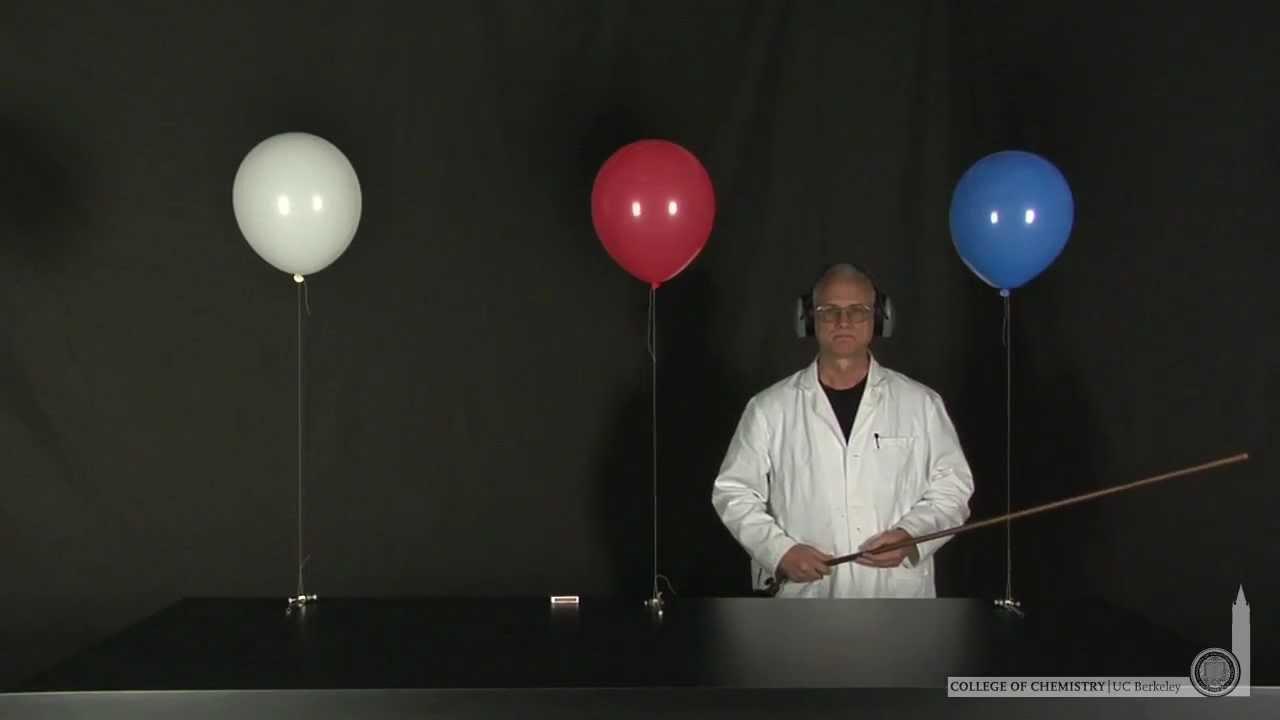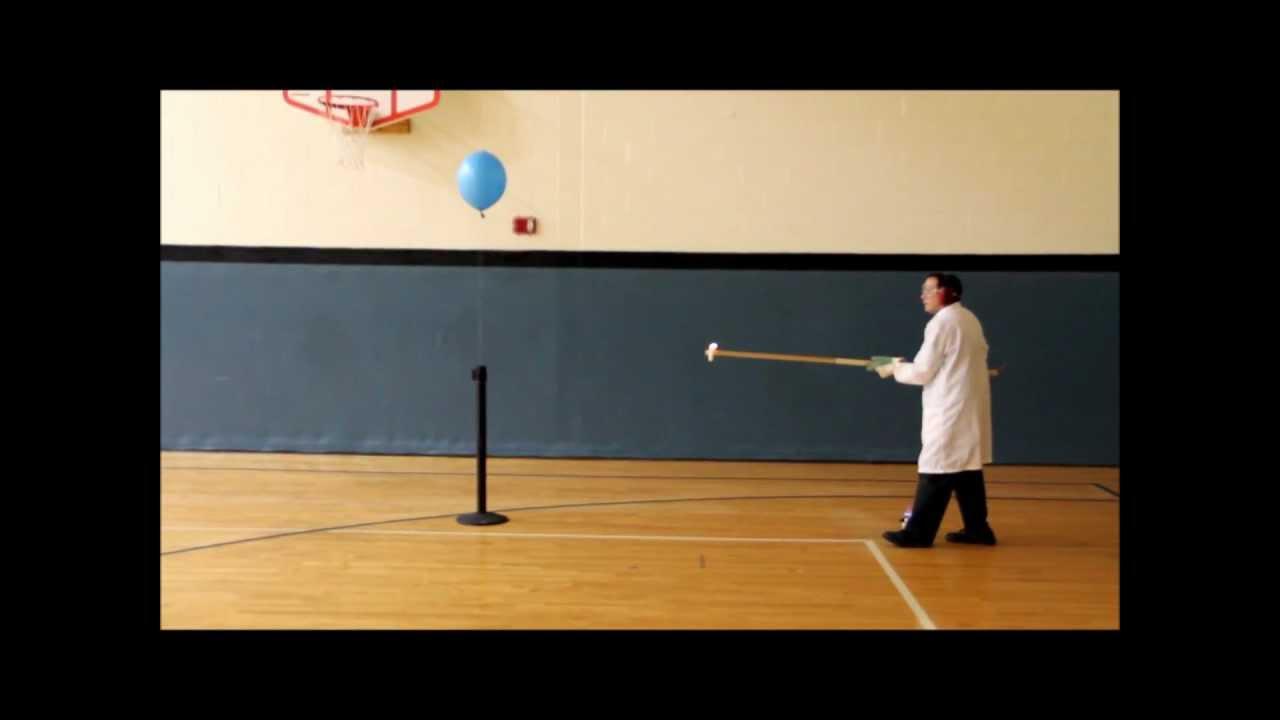The first image is the image on the left, the second image is the image on the right. Assess this claim about the two images: "The image on the right contains at least one blue balloon.". Correct or not? Answer yes or no. Yes. The first image is the image on the left, the second image is the image on the right. Evaluate the accuracy of this statement regarding the images: "One image shows exactly one human interacting with a single balloon in what could be a science demonstration, while the other image shows exactly three balloons.". Is it true? Answer yes or no. Yes. 